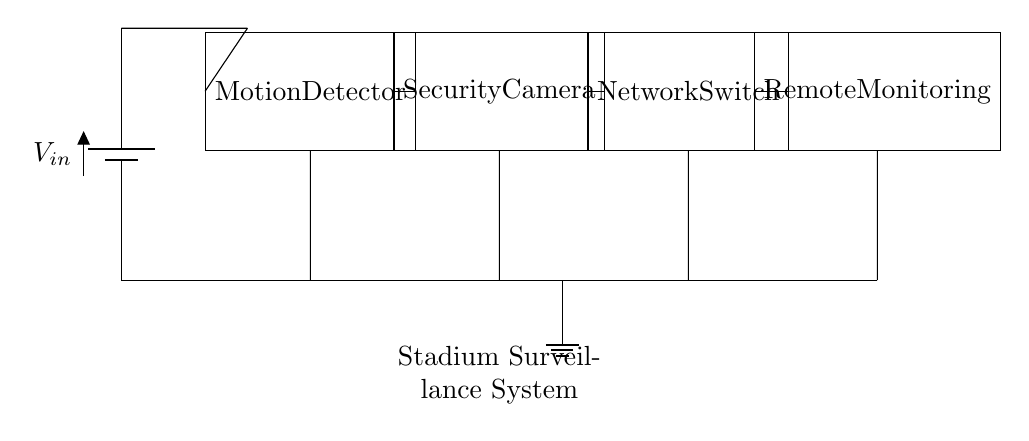What is the power source in this circuit? The battery labeled V_in serves as the power source for the circuit. It provides the necessary voltage for the operation of the components.
Answer: V_in How many main components are in the circuit? The circuit contains four main components: the motion detector, the security camera, the network switch, and the remote monitoring system. Each component is represented by a block in the diagram.
Answer: Four What is the purpose of the motion detector? The motion detector is designed to sense movement, triggering the security camera to activate and monitor activity in the stadium. Its role is critical for effective surveillance.
Answer: To sense movement What is the role of the network switch? The network switch facilitates communication between the security camera and the remote monitoring system, allowing the video feed to be sent for monitoring purposes.
Answer: To connect components How does the remote monitoring system receive data? The remote monitoring system receives data from the network switch, which forwards the video feed collected by the security camera. This is essential for real-time surveillance from off-site locations.
Answer: Through the network switch What is the ground connection for in this circuit? The ground connection provides a common reference point for all components in the circuit and is essential for safety and proper circuit function, helping to prevent electrical shock and equipment damage.
Answer: To provide a reference point 